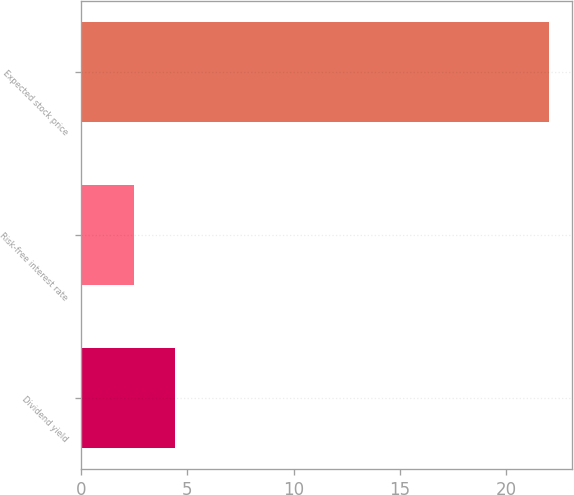<chart> <loc_0><loc_0><loc_500><loc_500><bar_chart><fcel>Dividend yield<fcel>Risk-free interest rate<fcel>Expected stock price<nl><fcel>4.43<fcel>2.48<fcel>22<nl></chart> 